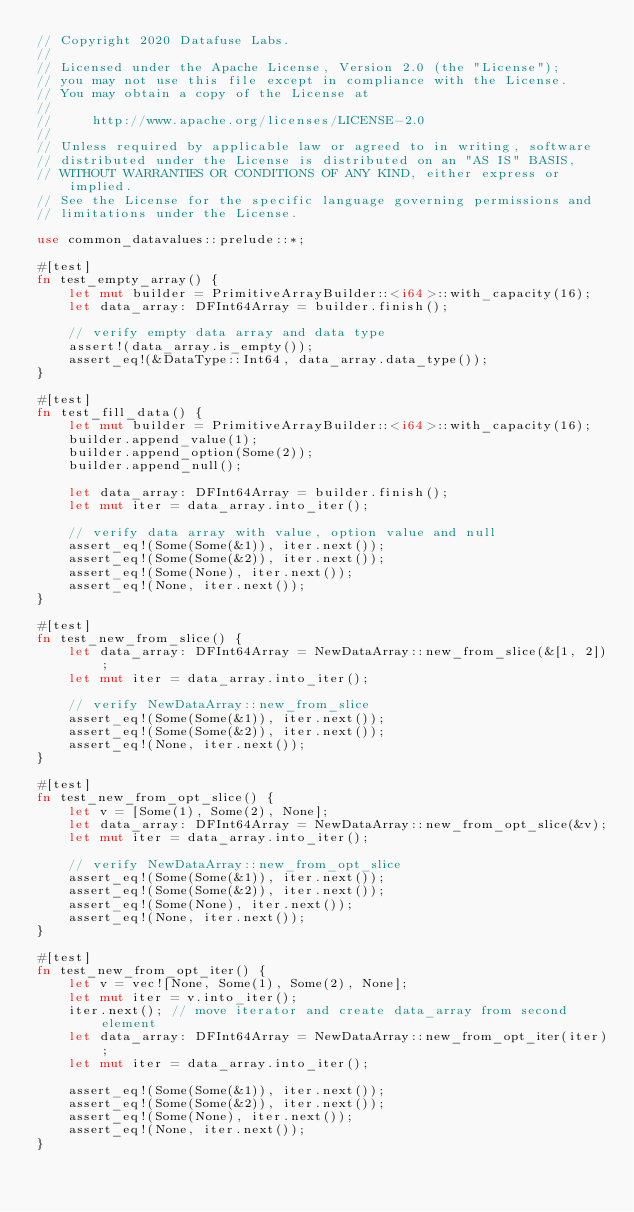<code> <loc_0><loc_0><loc_500><loc_500><_Rust_>// Copyright 2020 Datafuse Labs.
//
// Licensed under the Apache License, Version 2.0 (the "License");
// you may not use this file except in compliance with the License.
// You may obtain a copy of the License at
//
//     http://www.apache.org/licenses/LICENSE-2.0
//
// Unless required by applicable law or agreed to in writing, software
// distributed under the License is distributed on an "AS IS" BASIS,
// WITHOUT WARRANTIES OR CONDITIONS OF ANY KIND, either express or implied.
// See the License for the specific language governing permissions and
// limitations under the License.

use common_datavalues::prelude::*;

#[test]
fn test_empty_array() {
    let mut builder = PrimitiveArrayBuilder::<i64>::with_capacity(16);
    let data_array: DFInt64Array = builder.finish();

    // verify empty data array and data type
    assert!(data_array.is_empty());
    assert_eq!(&DataType::Int64, data_array.data_type());
}

#[test]
fn test_fill_data() {
    let mut builder = PrimitiveArrayBuilder::<i64>::with_capacity(16);
    builder.append_value(1);
    builder.append_option(Some(2));
    builder.append_null();

    let data_array: DFInt64Array = builder.finish();
    let mut iter = data_array.into_iter();

    // verify data array with value, option value and null
    assert_eq!(Some(Some(&1)), iter.next());
    assert_eq!(Some(Some(&2)), iter.next());
    assert_eq!(Some(None), iter.next());
    assert_eq!(None, iter.next());
}

#[test]
fn test_new_from_slice() {
    let data_array: DFInt64Array = NewDataArray::new_from_slice(&[1, 2]);
    let mut iter = data_array.into_iter();

    // verify NewDataArray::new_from_slice
    assert_eq!(Some(Some(&1)), iter.next());
    assert_eq!(Some(Some(&2)), iter.next());
    assert_eq!(None, iter.next());
}

#[test]
fn test_new_from_opt_slice() {
    let v = [Some(1), Some(2), None];
    let data_array: DFInt64Array = NewDataArray::new_from_opt_slice(&v);
    let mut iter = data_array.into_iter();

    // verify NewDataArray::new_from_opt_slice
    assert_eq!(Some(Some(&1)), iter.next());
    assert_eq!(Some(Some(&2)), iter.next());
    assert_eq!(Some(None), iter.next());
    assert_eq!(None, iter.next());
}

#[test]
fn test_new_from_opt_iter() {
    let v = vec![None, Some(1), Some(2), None];
    let mut iter = v.into_iter();
    iter.next(); // move iterator and create data_array from second element
    let data_array: DFInt64Array = NewDataArray::new_from_opt_iter(iter);
    let mut iter = data_array.into_iter();

    assert_eq!(Some(Some(&1)), iter.next());
    assert_eq!(Some(Some(&2)), iter.next());
    assert_eq!(Some(None), iter.next());
    assert_eq!(None, iter.next());
}
</code> 